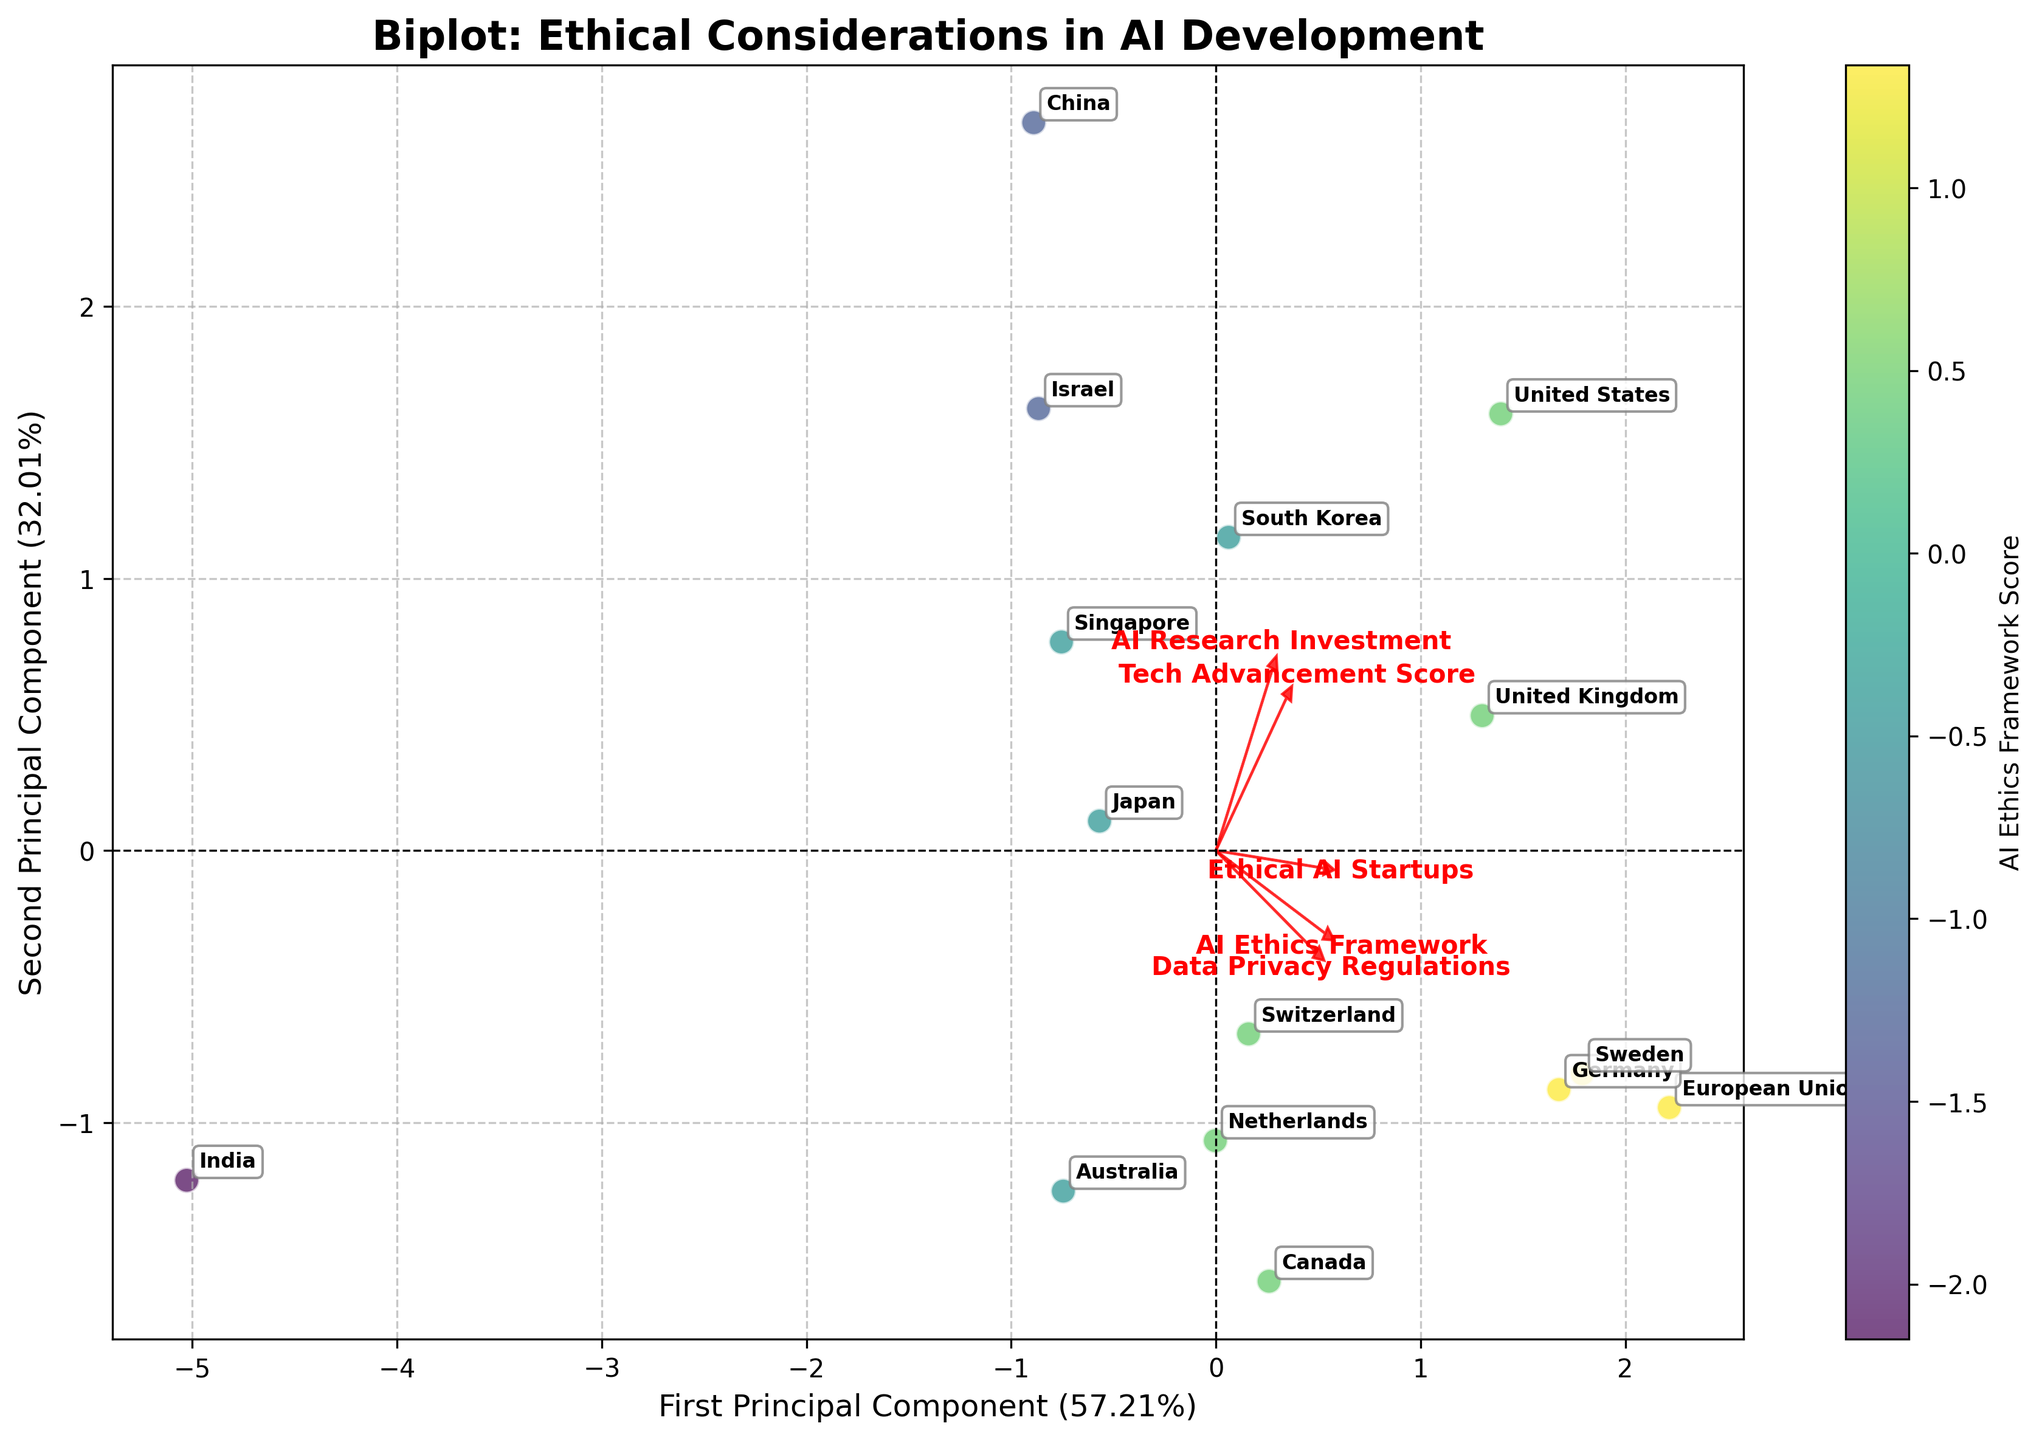What is the title of the figure? The title usually appears at the top of the figure. By looking at the top center area, you can see the heading that summarizes the plot's content and context.
Answer: Ethical Considerations in AI Development How many countries are represented in the plot? To determine the number of countries, count the unique labels annotating the plot. Each country has a distinct label adjacent to its corresponding plot point.
Answer: 15 Which country has the highest AI Ethics Framework score? The colorbar indicates AI Ethics Framework scores. The country with the deepest color saturation has the highest score. Examine the labels for the corresponding dark-colored point.
Answer: European Union How do AI Research Investment and Tech Advancement Score relate visually? Look at the arrows representing the two features. Their directions depict the nature of the relationship. If the arrows point in similar directions, the features are positively correlated. If they point in opposite directions or have a lesser angle, the correlation varies.
Answer: They are positively correlated Which country is positioned closest to the origin point (0,0)? Identify the plot's origin (0,0). The country closest to this intersection is the one whose labeled point is nearest this center point.
Answer: Israel Is there a negative correlation between Data Privacy Regulations and Ethical AI Startups? Check the direction of the arrows for these features. If they point in roughly opposite directions, there is a negative correlation.
Answer: No, they are positively correlated Which two countries have similar positions in the PCA plot in terms of their PC1 and PC2 values? Identify closely clustered points on the plot. Compare their annotations to find similar PCA positions.
Answer: Canada and Netherlands Based on the plot, which feature contributes most to the First Principal Component? The lengths of the arrows indicate the level of contribution. The longest arrow along the First Principal Component axis indicates the most significant contribution.
Answer: Tech Advancement Score Do countries with higher AI Ethics Framework scores cluster in a particular region of the plot? Analyze the regions formed by different color intensities. Countries with similar high AI Ethics Framework scores will be near each other if they cluster.
Answer: Yes, they generally cluster How are India and Sweden positioned relative to each other in the plot? Locate the labels for India and Sweden. Determine their positions by comparing the distances and directions of their points relative to each other on the plot.
Answer: Sweden is positioned towards the higher PCA values compared to India; generally, to the right and slightly down 